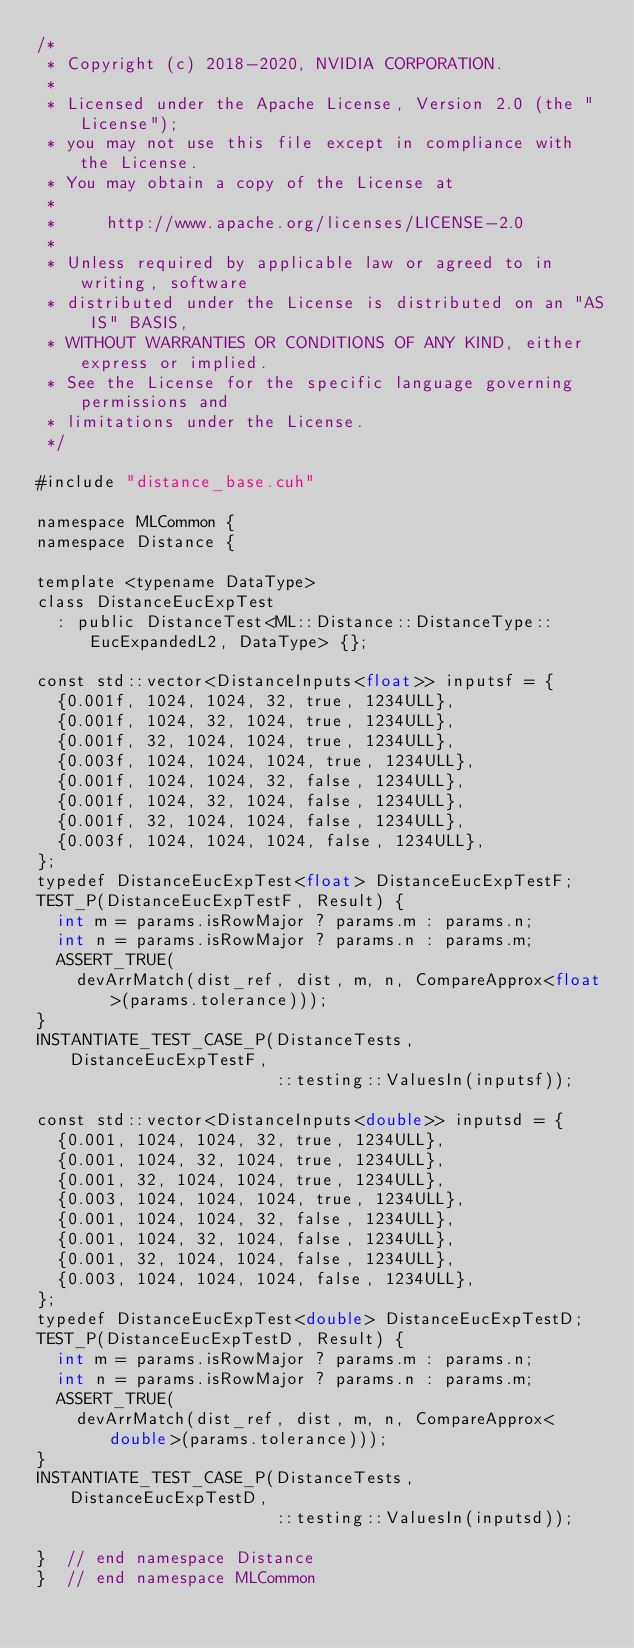<code> <loc_0><loc_0><loc_500><loc_500><_Cuda_>/*
 * Copyright (c) 2018-2020, NVIDIA CORPORATION.
 *
 * Licensed under the Apache License, Version 2.0 (the "License");
 * you may not use this file except in compliance with the License.
 * You may obtain a copy of the License at
 *
 *     http://www.apache.org/licenses/LICENSE-2.0
 *
 * Unless required by applicable law or agreed to in writing, software
 * distributed under the License is distributed on an "AS IS" BASIS,
 * WITHOUT WARRANTIES OR CONDITIONS OF ANY KIND, either express or implied.
 * See the License for the specific language governing permissions and
 * limitations under the License.
 */

#include "distance_base.cuh"

namespace MLCommon {
namespace Distance {

template <typename DataType>
class DistanceEucExpTest
  : public DistanceTest<ML::Distance::DistanceType::EucExpandedL2, DataType> {};

const std::vector<DistanceInputs<float>> inputsf = {
  {0.001f, 1024, 1024, 32, true, 1234ULL},
  {0.001f, 1024, 32, 1024, true, 1234ULL},
  {0.001f, 32, 1024, 1024, true, 1234ULL},
  {0.003f, 1024, 1024, 1024, true, 1234ULL},
  {0.001f, 1024, 1024, 32, false, 1234ULL},
  {0.001f, 1024, 32, 1024, false, 1234ULL},
  {0.001f, 32, 1024, 1024, false, 1234ULL},
  {0.003f, 1024, 1024, 1024, false, 1234ULL},
};
typedef DistanceEucExpTest<float> DistanceEucExpTestF;
TEST_P(DistanceEucExpTestF, Result) {
  int m = params.isRowMajor ? params.m : params.n;
  int n = params.isRowMajor ? params.n : params.m;
  ASSERT_TRUE(
    devArrMatch(dist_ref, dist, m, n, CompareApprox<float>(params.tolerance)));
}
INSTANTIATE_TEST_CASE_P(DistanceTests, DistanceEucExpTestF,
                        ::testing::ValuesIn(inputsf));

const std::vector<DistanceInputs<double>> inputsd = {
  {0.001, 1024, 1024, 32, true, 1234ULL},
  {0.001, 1024, 32, 1024, true, 1234ULL},
  {0.001, 32, 1024, 1024, true, 1234ULL},
  {0.003, 1024, 1024, 1024, true, 1234ULL},
  {0.001, 1024, 1024, 32, false, 1234ULL},
  {0.001, 1024, 32, 1024, false, 1234ULL},
  {0.001, 32, 1024, 1024, false, 1234ULL},
  {0.003, 1024, 1024, 1024, false, 1234ULL},
};
typedef DistanceEucExpTest<double> DistanceEucExpTestD;
TEST_P(DistanceEucExpTestD, Result) {
  int m = params.isRowMajor ? params.m : params.n;
  int n = params.isRowMajor ? params.n : params.m;
  ASSERT_TRUE(
    devArrMatch(dist_ref, dist, m, n, CompareApprox<double>(params.tolerance)));
}
INSTANTIATE_TEST_CASE_P(DistanceTests, DistanceEucExpTestD,
                        ::testing::ValuesIn(inputsd));

}  // end namespace Distance
}  // end namespace MLCommon
</code> 